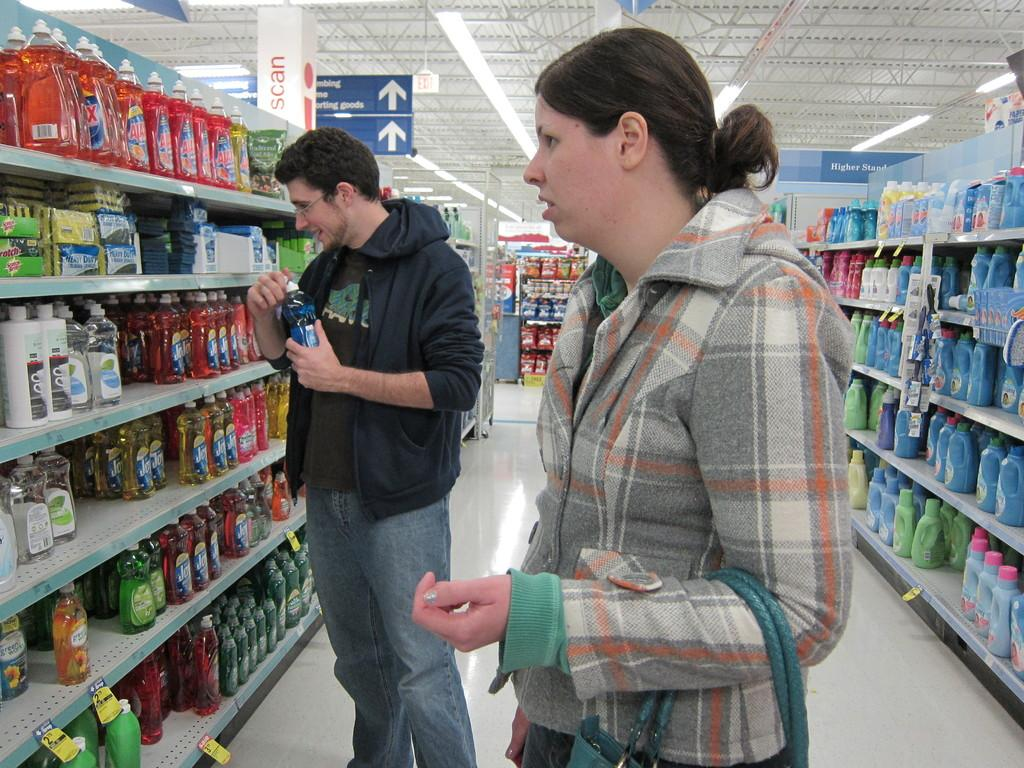<image>
Share a concise interpretation of the image provided. Man and woman is shopping in a store for dish detergent 